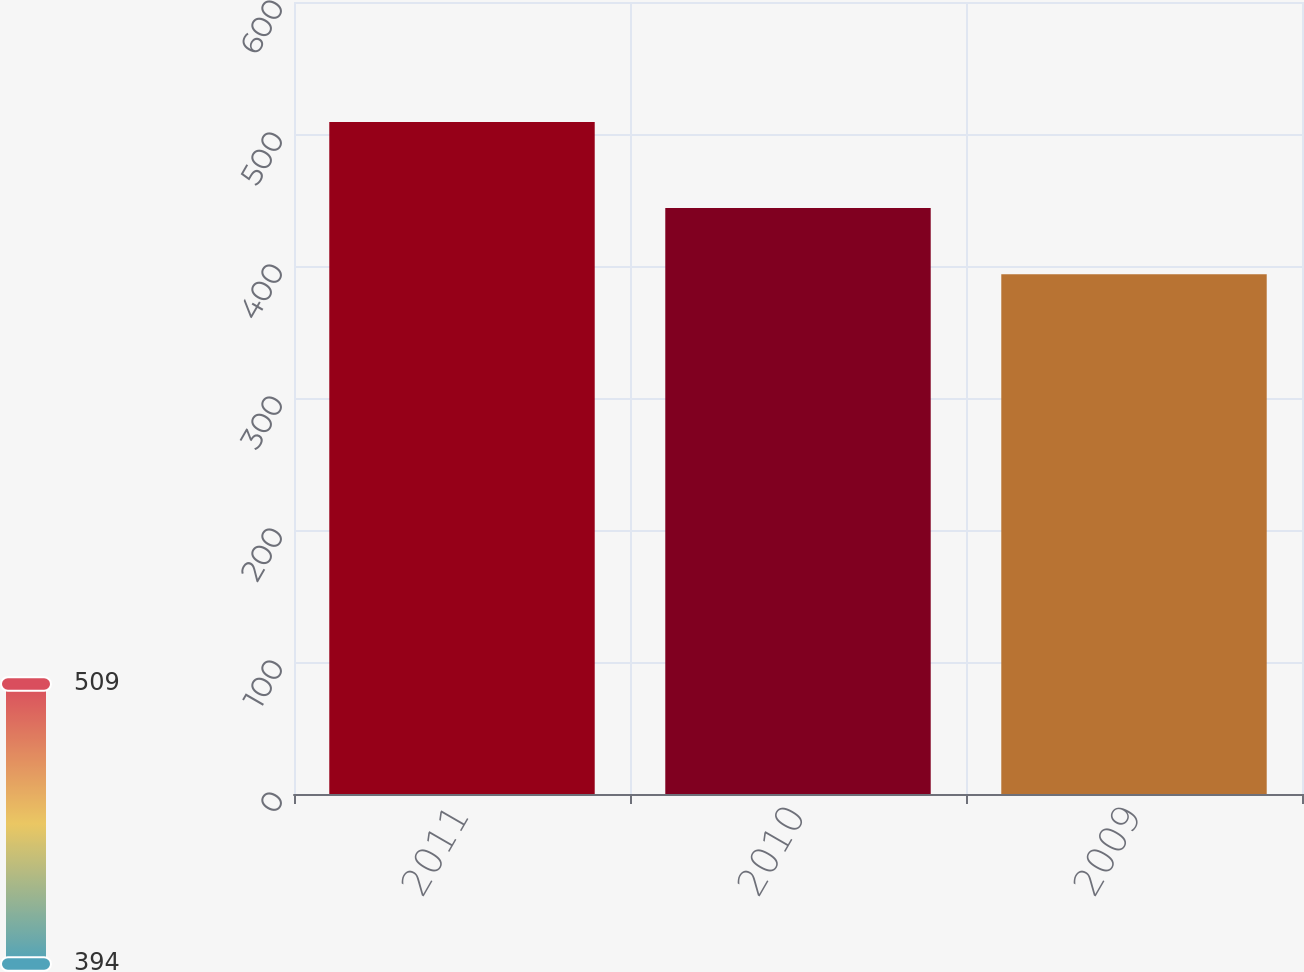<chart> <loc_0><loc_0><loc_500><loc_500><bar_chart><fcel>2011<fcel>2010<fcel>2009<nl><fcel>509.1<fcel>444<fcel>393.7<nl></chart> 